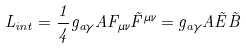<formula> <loc_0><loc_0><loc_500><loc_500>L _ { i n t } = \frac { 1 } { 4 } g _ { a \gamma } A F _ { \mu \nu } \tilde { F } ^ { \mu \nu } = g _ { a \gamma } A \vec { E } \vec { B }</formula> 